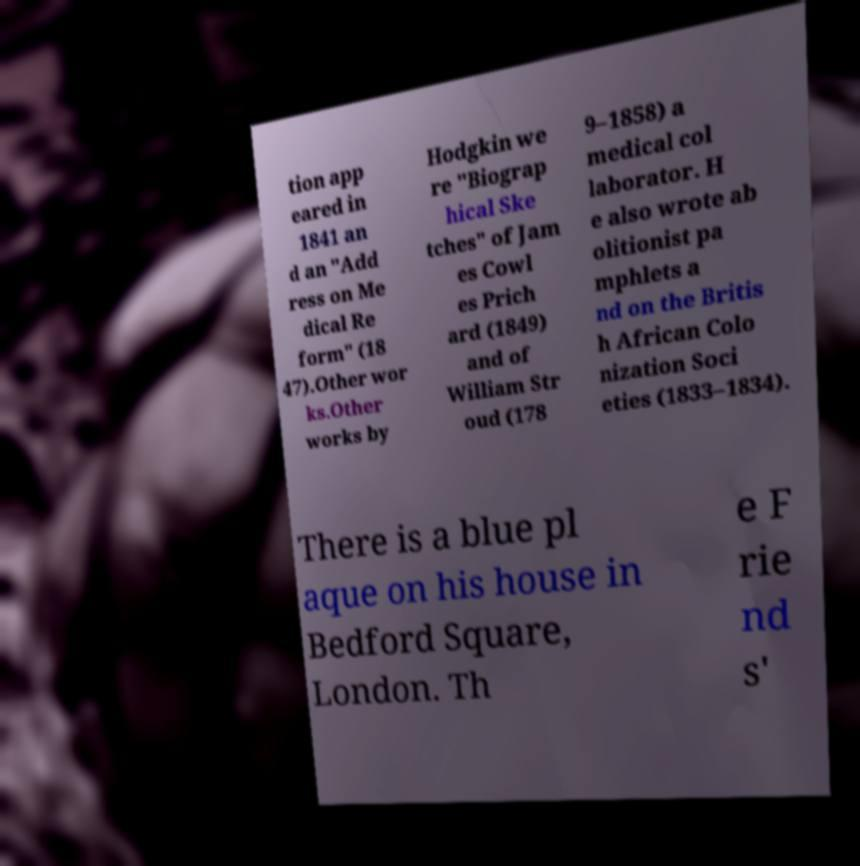Please identify and transcribe the text found in this image. tion app eared in 1841 an d an "Add ress on Me dical Re form" (18 47).Other wor ks.Other works by Hodgkin we re "Biograp hical Ske tches" of Jam es Cowl es Prich ard (1849) and of William Str oud (178 9–1858) a medical col laborator. H e also wrote ab olitionist pa mphlets a nd on the Britis h African Colo nization Soci eties (1833–1834). There is a blue pl aque on his house in Bedford Square, London. Th e F rie nd s' 